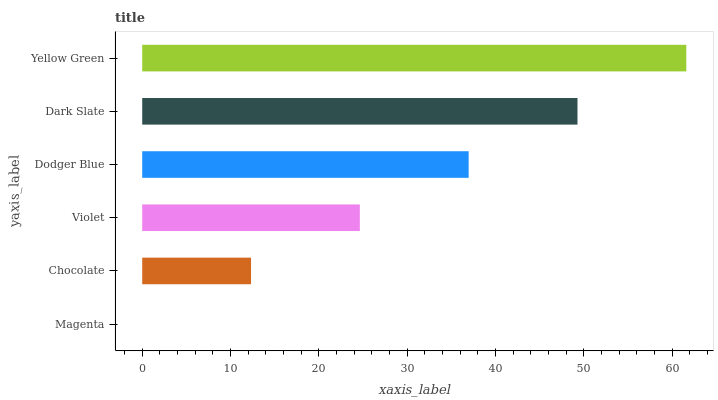Is Magenta the minimum?
Answer yes or no. Yes. Is Yellow Green the maximum?
Answer yes or no. Yes. Is Chocolate the minimum?
Answer yes or no. No. Is Chocolate the maximum?
Answer yes or no. No. Is Chocolate greater than Magenta?
Answer yes or no. Yes. Is Magenta less than Chocolate?
Answer yes or no. Yes. Is Magenta greater than Chocolate?
Answer yes or no. No. Is Chocolate less than Magenta?
Answer yes or no. No. Is Dodger Blue the high median?
Answer yes or no. Yes. Is Violet the low median?
Answer yes or no. Yes. Is Chocolate the high median?
Answer yes or no. No. Is Magenta the low median?
Answer yes or no. No. 